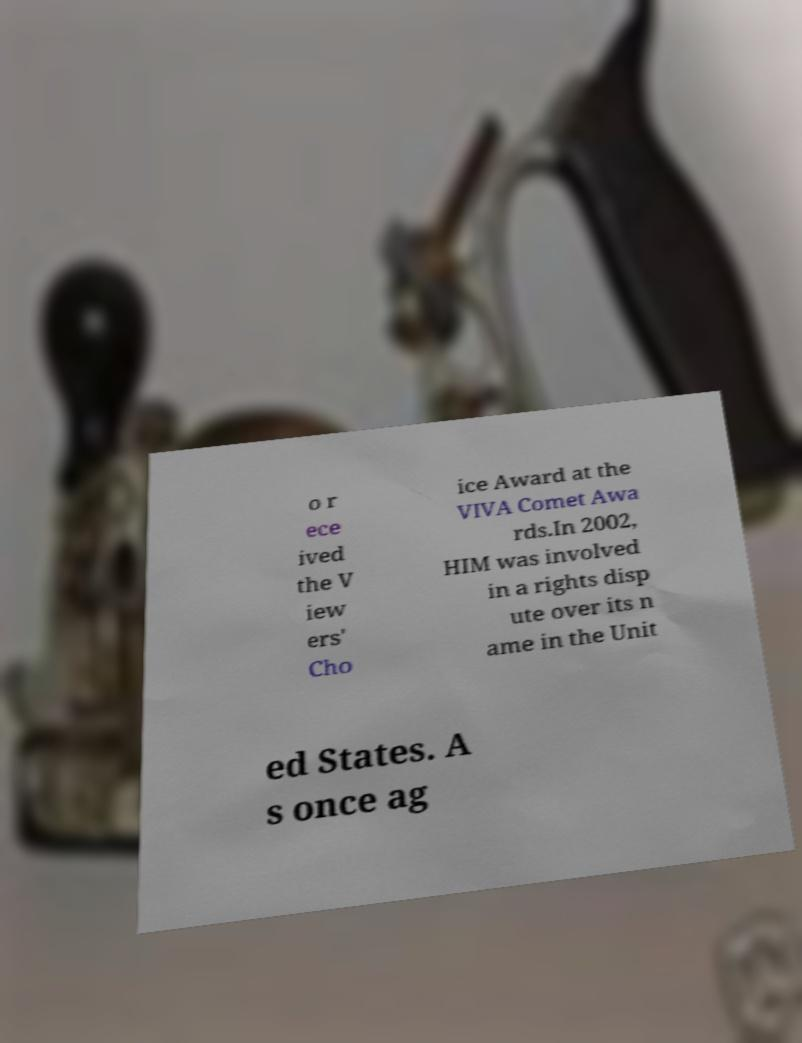Can you accurately transcribe the text from the provided image for me? o r ece ived the V iew ers' Cho ice Award at the VIVA Comet Awa rds.In 2002, HIM was involved in a rights disp ute over its n ame in the Unit ed States. A s once ag 